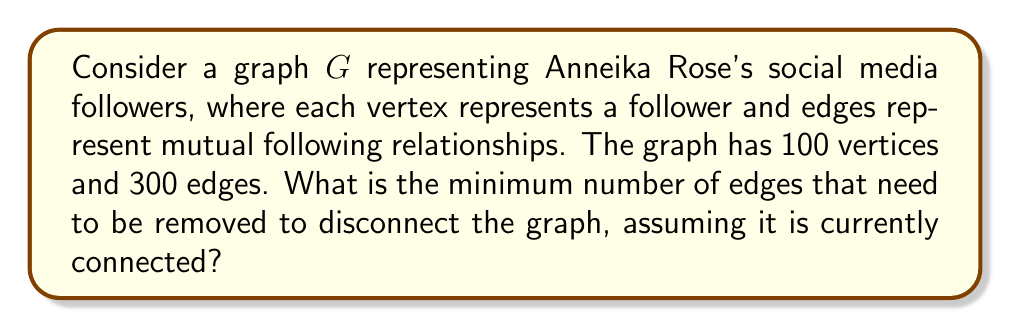Could you help me with this problem? To solve this problem, we need to understand the concept of edge connectivity in graph theory.

1. Edge connectivity of a graph is defined as the minimum number of edges that need to be removed to disconnect the graph.

2. For any connected graph $G$ with $n$ vertices, the edge connectivity $\kappa'(G)$ is always less than or equal to the minimum degree $\delta(G)$ of the graph:

   $$\kappa'(G) \leq \delta(G)$$

3. To find the minimum degree, we can use the handshaking lemma:
   $$\sum_{v \in V} \deg(v) = 2|E|$$

   Where $|E|$ is the number of edges in the graph.

4. In this case, we have 100 vertices and 300 edges:
   $$\sum_{v \in V} \deg(v) = 2 * 300 = 600$$

5. The average degree is:
   $$\frac{600}{100} = 6$$

6. Since the minimum degree is an integer and must be less than or equal to the average degree, we can conclude that:
   $$\delta(G) \leq 6$$

7. Therefore, the edge connectivity of the graph is at most 6:
   $$\kappa'(G) \leq \delta(G) \leq 6$$

8. This means that at most 6 edges need to be removed to disconnect the graph.

Given that Anneika Rose is a successful actress, it's reasonable to assume her social media following is well-connected. Therefore, the minimum number of edges to be removed to disconnect the graph is likely to be equal to the upper bound we calculated.
Answer: 6 edges 